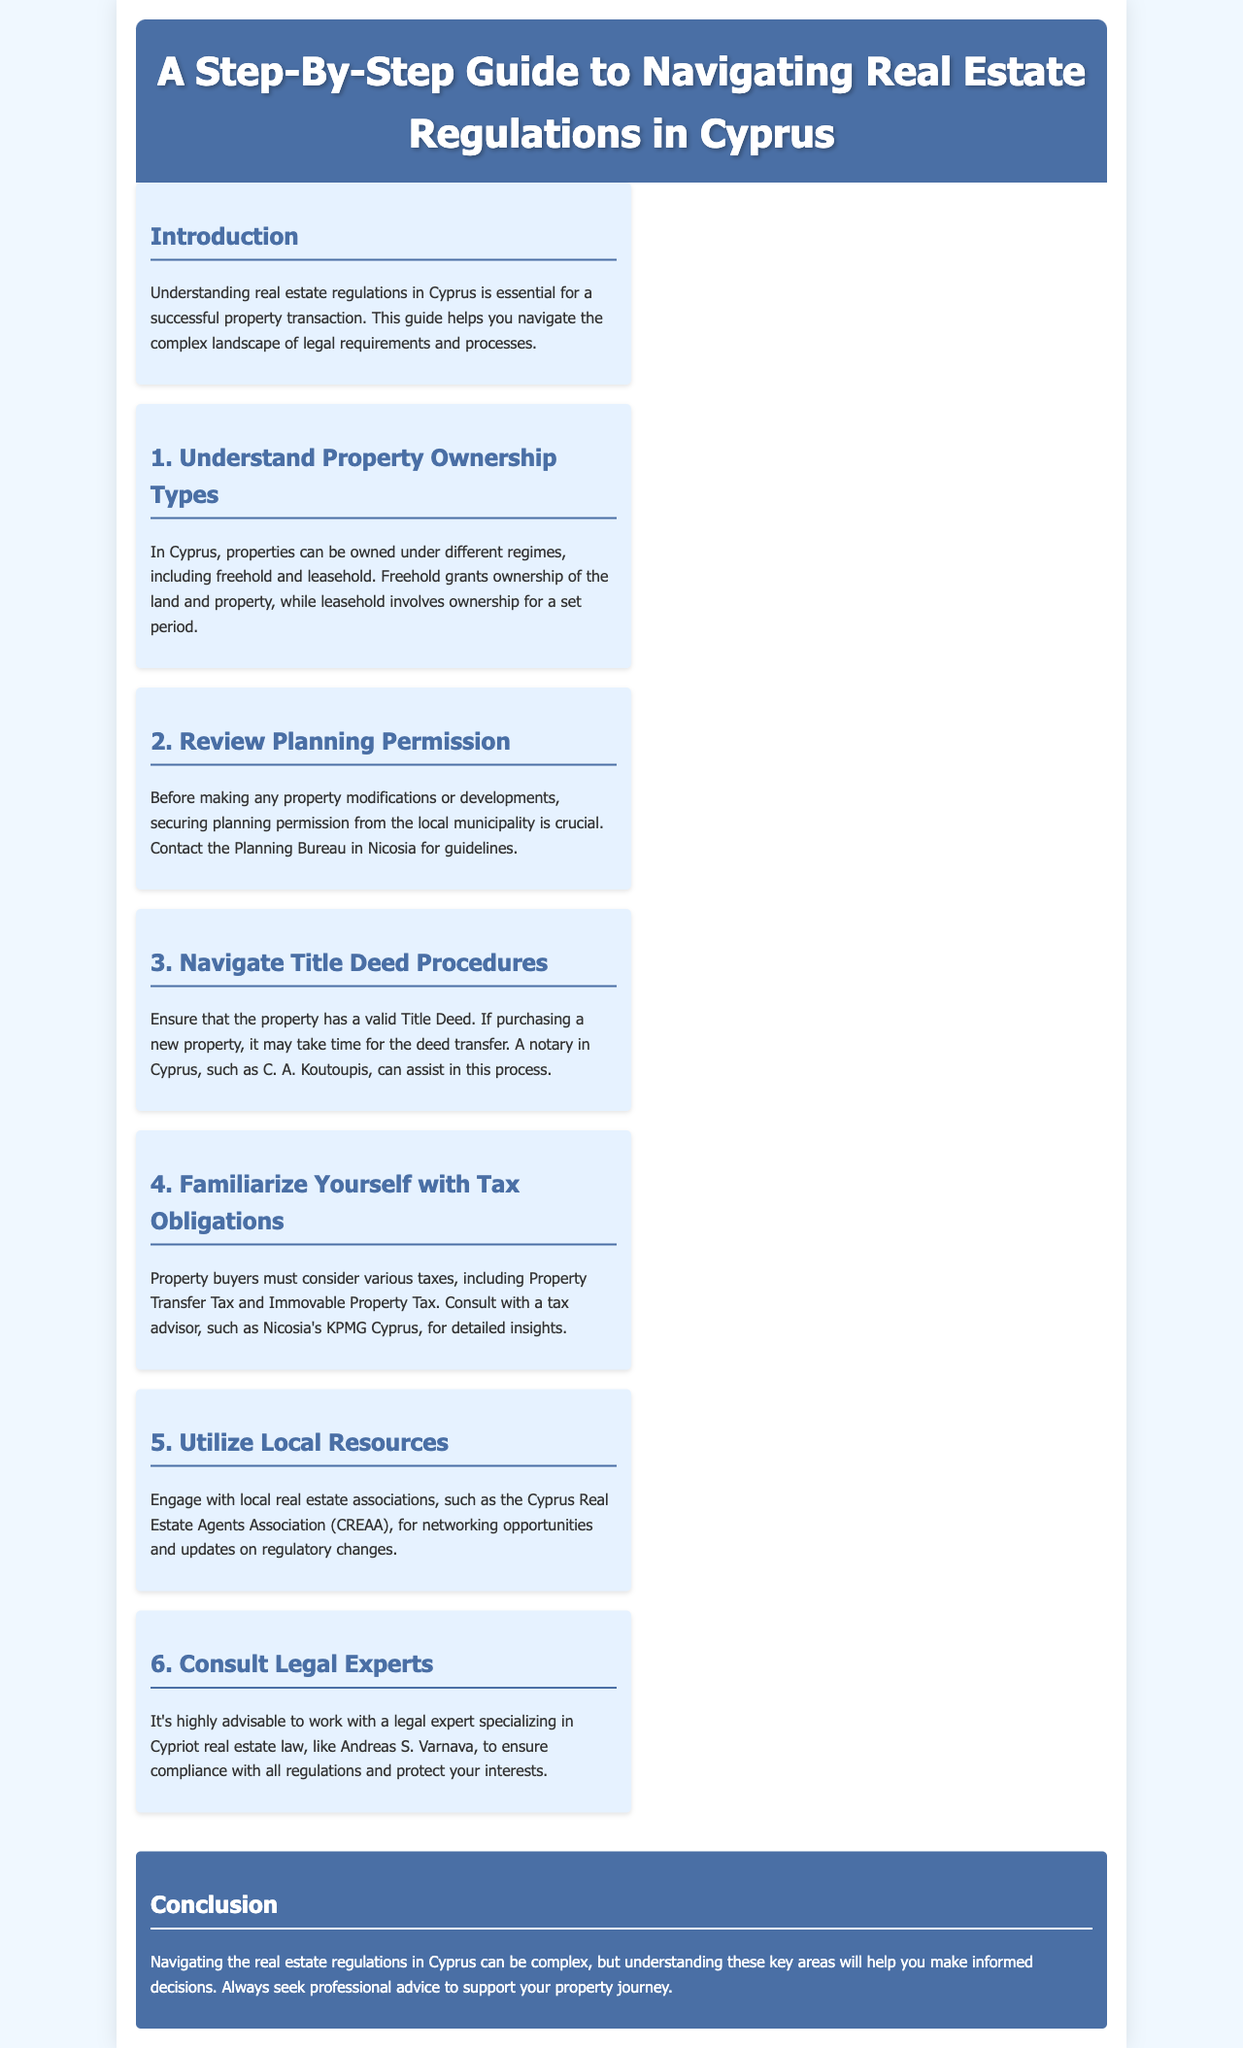What types of property ownership are available in Cyprus? The document mentions that properties can be owned under different regimes, including freehold and leasehold.
Answer: freehold and leasehold What is the first step when considering property modifications? The document states that securing planning permission from the local municipality is crucial before making any property modifications.
Answer: planning permission Who can assist with the Title Deed procedures? The document suggests that a notary in Cyprus, such as C. A. Koutoupis, can assist in the Title Deed process.
Answer: C. A. Koutoupis What types of taxes must property buyers consider? The document lists Property Transfer Tax and Immovable Property Tax as taxes that property buyers should consider.
Answer: Property Transfer Tax and Immovable Property Tax Which local association can provide networking opportunities? The document refers to the Cyprus Real Estate Agents Association (CREAA) as a resource for networking opportunities.
Answer: Cyprus Real Estate Agents Association (CREAA) What is the recommendation for working with legal experts? The document highly advises working with a legal expert specializing in Cypriot real estate law.
Answer: work with a legal expert What is the main purpose of this guide? The document emphasizes that understanding real estate regulations in Cyprus is essential for a successful property transaction.
Answer: successful property transaction What is stated about seeking professional advice? The document concludes with a reminder that always seeking professional advice supports your property journey.
Answer: always seek professional advice 